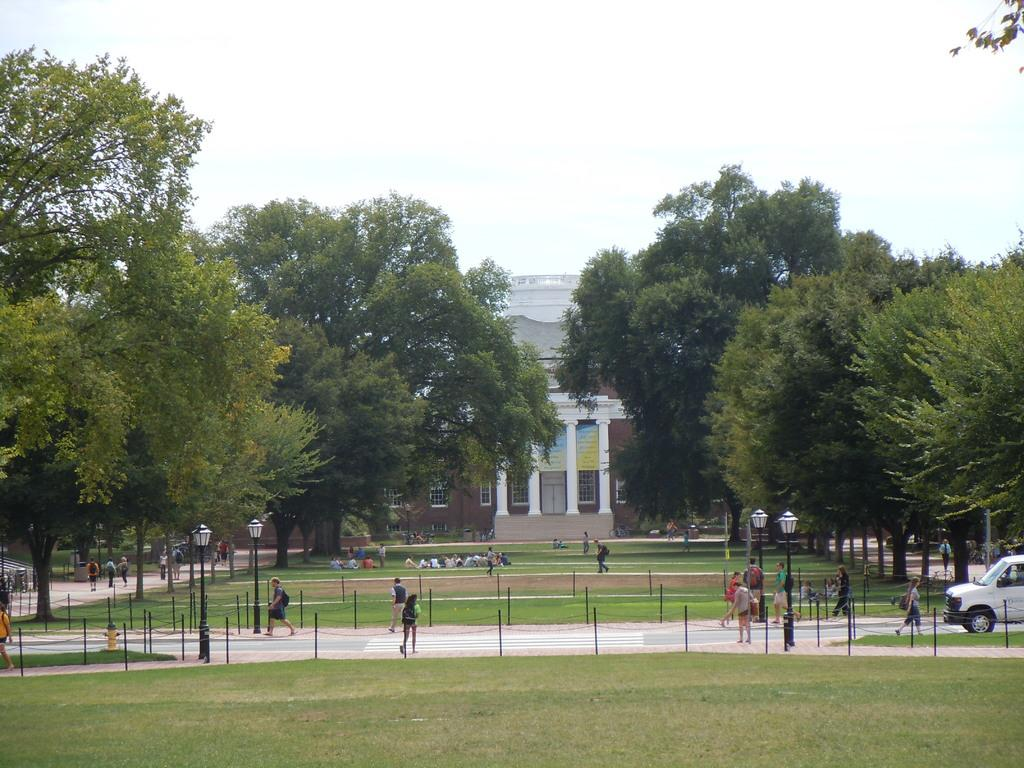What type of institution is shown in the image? The image depicts a university. What can be observed about the people within the university? There are many students moving around the university. Are there any green spaces within the university? Yes, there is a garden within the university. What is the surrounding environment of the garden like? There are a lot of trees surrounding the garden. Can you see a bird flying over the university in the image? There is no bird visible in the image. Is there a receipt for a purchase made at the university in the image? There is no receipt present in the image. 